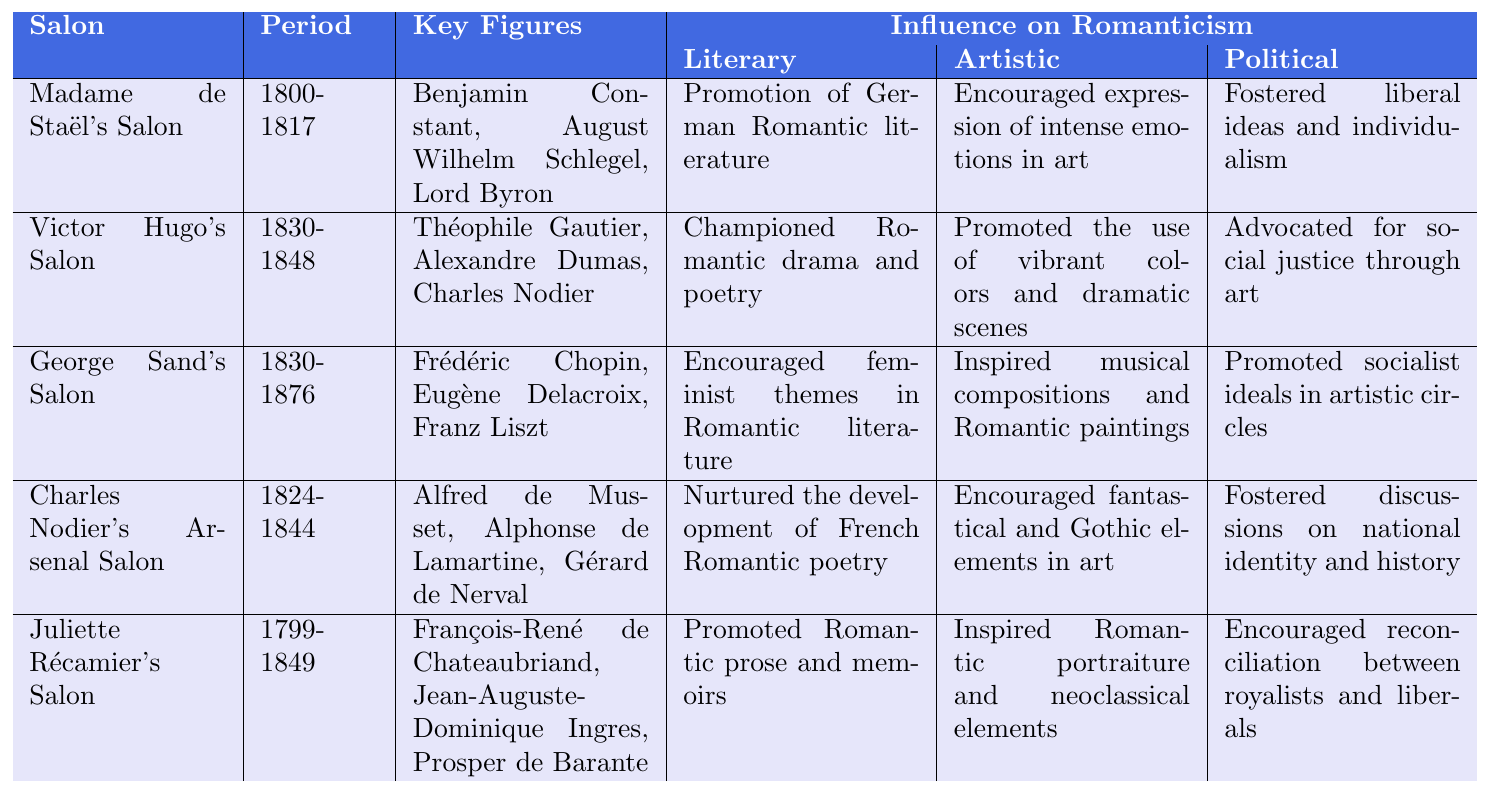What is the period of Madame de Staël's Salon? The table shows that Madame de Staël's Salon occurred during the years 1800-1817.
Answer: 1800-1817 Who were the key figures in Victor Hugo's Salon? According to the table, the key figures in Victor Hugo's Salon included Théophile Gautier, Alexandre Dumas, and Charles Nodier.
Answer: Théophile Gautier, Alexandre Dumas, Charles Nodier What was the artistic influence of George Sand's Salon? The table lists that the artistic influence of George Sand's Salon was to inspire musical compositions and Romantic paintings.
Answer: Inspired musical compositions and Romantic paintings Does Juliette Récamier's Salon promote any political ideals? Yes, the table states that Juliette Récamier's Salon encouraged reconciliation between royalists and liberals, indicating a political influence.
Answer: Yes How many salons influenced Romanticism during the period of 1824-1848? The table shows that there is one salon, Charles Nodier's Arsenal Salon, that influenced Romanticism during the period of 1824-1848.
Answer: One Which salon focused on feminist themes in literature? The table indicates George Sand's Salon as the one that encouraged feminist themes in Romantic literature.
Answer: George Sand's Salon What is the cumulative number of influential key figures across all salons presented in the table? Each salon has three key figures, and there are five salons listed. Therefore, the cumulative count is 3 (key figures per salon) × 5 (salons) = 15 key figures in total.
Answer: 15 Compare the literary influence of Madame de Staël's Salon to that of Charles Nodier's Arsenal Salon. Madame de Staël's Salon promoted German Romantic literature, while Charles Nodier's Arsenal Salon nurtured the development of French Romantic poetry. This shows a different focus, with one being on a specific national literature and the other on a genre of poetry.
Answer: Different focuses Which salon lasted the longest, and what was its influence? The longest-lasting salon is George Sand's Salon, which operated from 1830 to 1876. Its influences included encouraging feminist themes, inspiring musical compositions, and promoting socialist ideals.
Answer: George Sand's Salon; influence: feminist themes, music, socialism Did any salon advocate for social justice through art? Yes, Victor Hugo's Salon explicitly advocated for social justice through art, as stated in the table.
Answer: Yes 